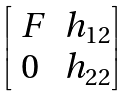Convert formula to latex. <formula><loc_0><loc_0><loc_500><loc_500>\begin{bmatrix} \ F & h _ { 1 2 } \\ 0 & h _ { 2 2 } \end{bmatrix}</formula> 